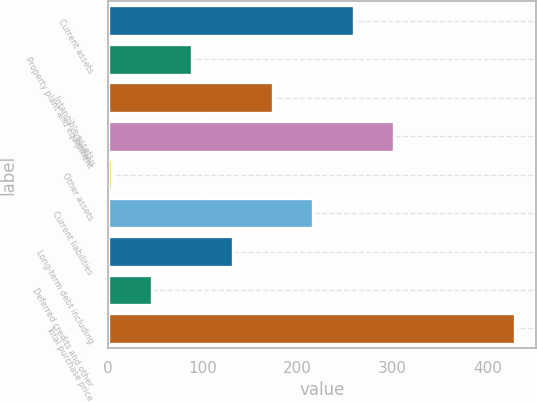Convert chart. <chart><loc_0><loc_0><loc_500><loc_500><bar_chart><fcel>Current assets<fcel>Property plant and equipment<fcel>Intangible assets<fcel>Goodwill<fcel>Other assets<fcel>Current liabilities<fcel>Long-term debt including<fcel>Deferred credits and other<fcel>Total purchase price<nl><fcel>259<fcel>89<fcel>174<fcel>301.5<fcel>4<fcel>216.5<fcel>131.5<fcel>46.5<fcel>429<nl></chart> 